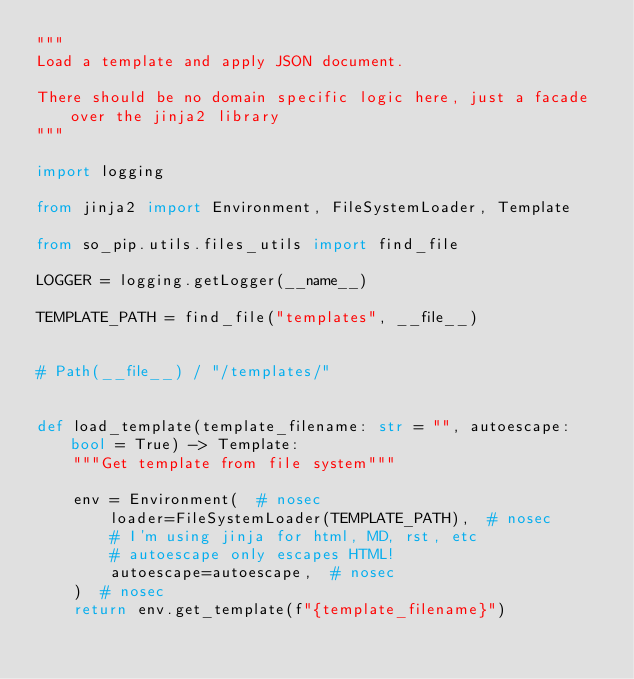<code> <loc_0><loc_0><loc_500><loc_500><_Python_>"""
Load a template and apply JSON document.

There should be no domain specific logic here, just a facade over the jinja2 library
"""

import logging

from jinja2 import Environment, FileSystemLoader, Template

from so_pip.utils.files_utils import find_file

LOGGER = logging.getLogger(__name__)

TEMPLATE_PATH = find_file("templates", __file__)


# Path(__file__) / "/templates/"


def load_template(template_filename: str = "", autoescape: bool = True) -> Template:
    """Get template from file system"""

    env = Environment(  # nosec
        loader=FileSystemLoader(TEMPLATE_PATH),  # nosec
        # I'm using jinja for html, MD, rst, etc
        # autoescape only escapes HTML!
        autoescape=autoescape,  # nosec
    )  # nosec
    return env.get_template(f"{template_filename}")
</code> 